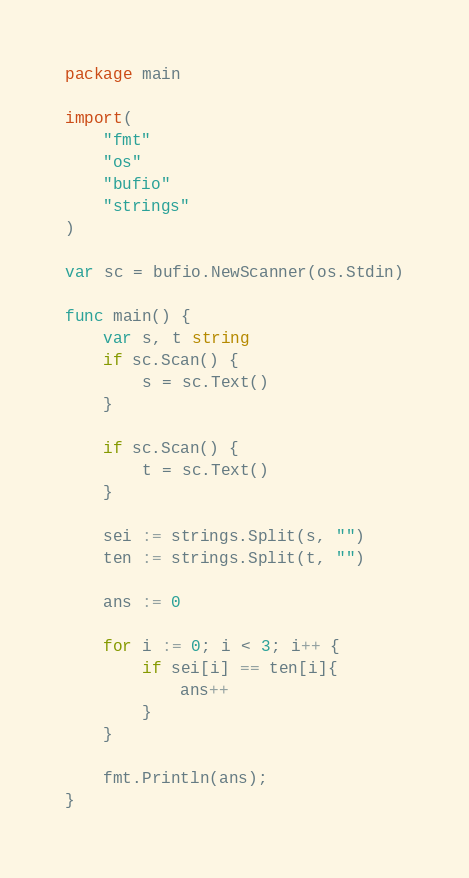<code> <loc_0><loc_0><loc_500><loc_500><_Go_>package main

import(
	"fmt"
	"os"
	"bufio"
	"strings"
)

var sc = bufio.NewScanner(os.Stdin)

func main() {
	var s, t string
	if sc.Scan() {
		s = sc.Text()
	}

	if sc.Scan() {
		t = sc.Text()
	}

	sei := strings.Split(s, "")
	ten := strings.Split(t, "")

	ans := 0

	for i := 0; i < 3; i++ {
		if sei[i] == ten[i]{
			ans++
		}
	}

	fmt.Println(ans);
}</code> 